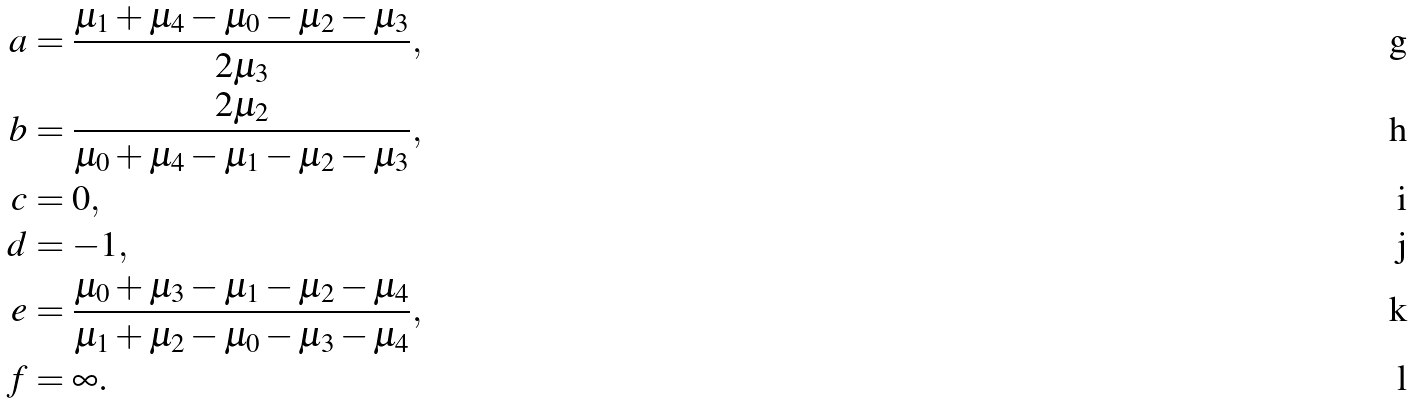Convert formula to latex. <formula><loc_0><loc_0><loc_500><loc_500>a & = \frac { \mu _ { 1 } + \mu _ { 4 } - \mu _ { 0 } - \mu _ { 2 } - \mu _ { 3 } } { 2 \mu _ { 3 } } , \\ b & = \frac { 2 \mu _ { 2 } } { \mu _ { 0 } + \mu _ { 4 } - \mu _ { 1 } - \mu _ { 2 } - \mu _ { 3 } } , \\ c & = 0 , \\ d & = - 1 , \\ e & = \frac { \mu _ { 0 } + \mu _ { 3 } - \mu _ { 1 } - \mu _ { 2 } - \mu _ { 4 } } { \mu _ { 1 } + \mu _ { 2 } - \mu _ { 0 } - \mu _ { 3 } - \mu _ { 4 } } , \\ f & = \infty .</formula> 